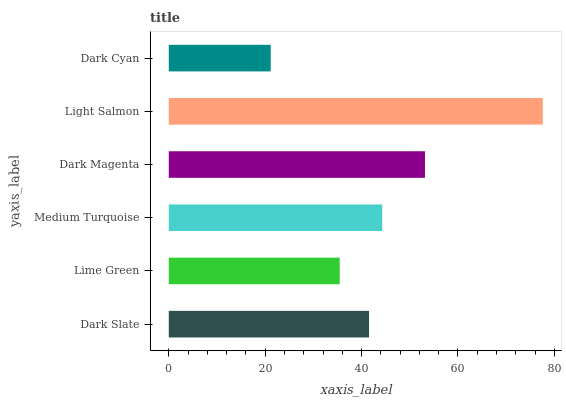Is Dark Cyan the minimum?
Answer yes or no. Yes. Is Light Salmon the maximum?
Answer yes or no. Yes. Is Lime Green the minimum?
Answer yes or no. No. Is Lime Green the maximum?
Answer yes or no. No. Is Dark Slate greater than Lime Green?
Answer yes or no. Yes. Is Lime Green less than Dark Slate?
Answer yes or no. Yes. Is Lime Green greater than Dark Slate?
Answer yes or no. No. Is Dark Slate less than Lime Green?
Answer yes or no. No. Is Medium Turquoise the high median?
Answer yes or no. Yes. Is Dark Slate the low median?
Answer yes or no. Yes. Is Light Salmon the high median?
Answer yes or no. No. Is Dark Cyan the low median?
Answer yes or no. No. 